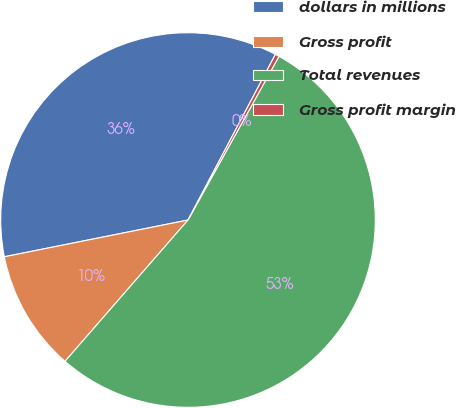Convert chart. <chart><loc_0><loc_0><loc_500><loc_500><pie_chart><fcel>dollars in millions<fcel>Gross profit<fcel>Total revenues<fcel>Gross profit margin<nl><fcel>35.87%<fcel>10.46%<fcel>53.32%<fcel>0.35%<nl></chart> 